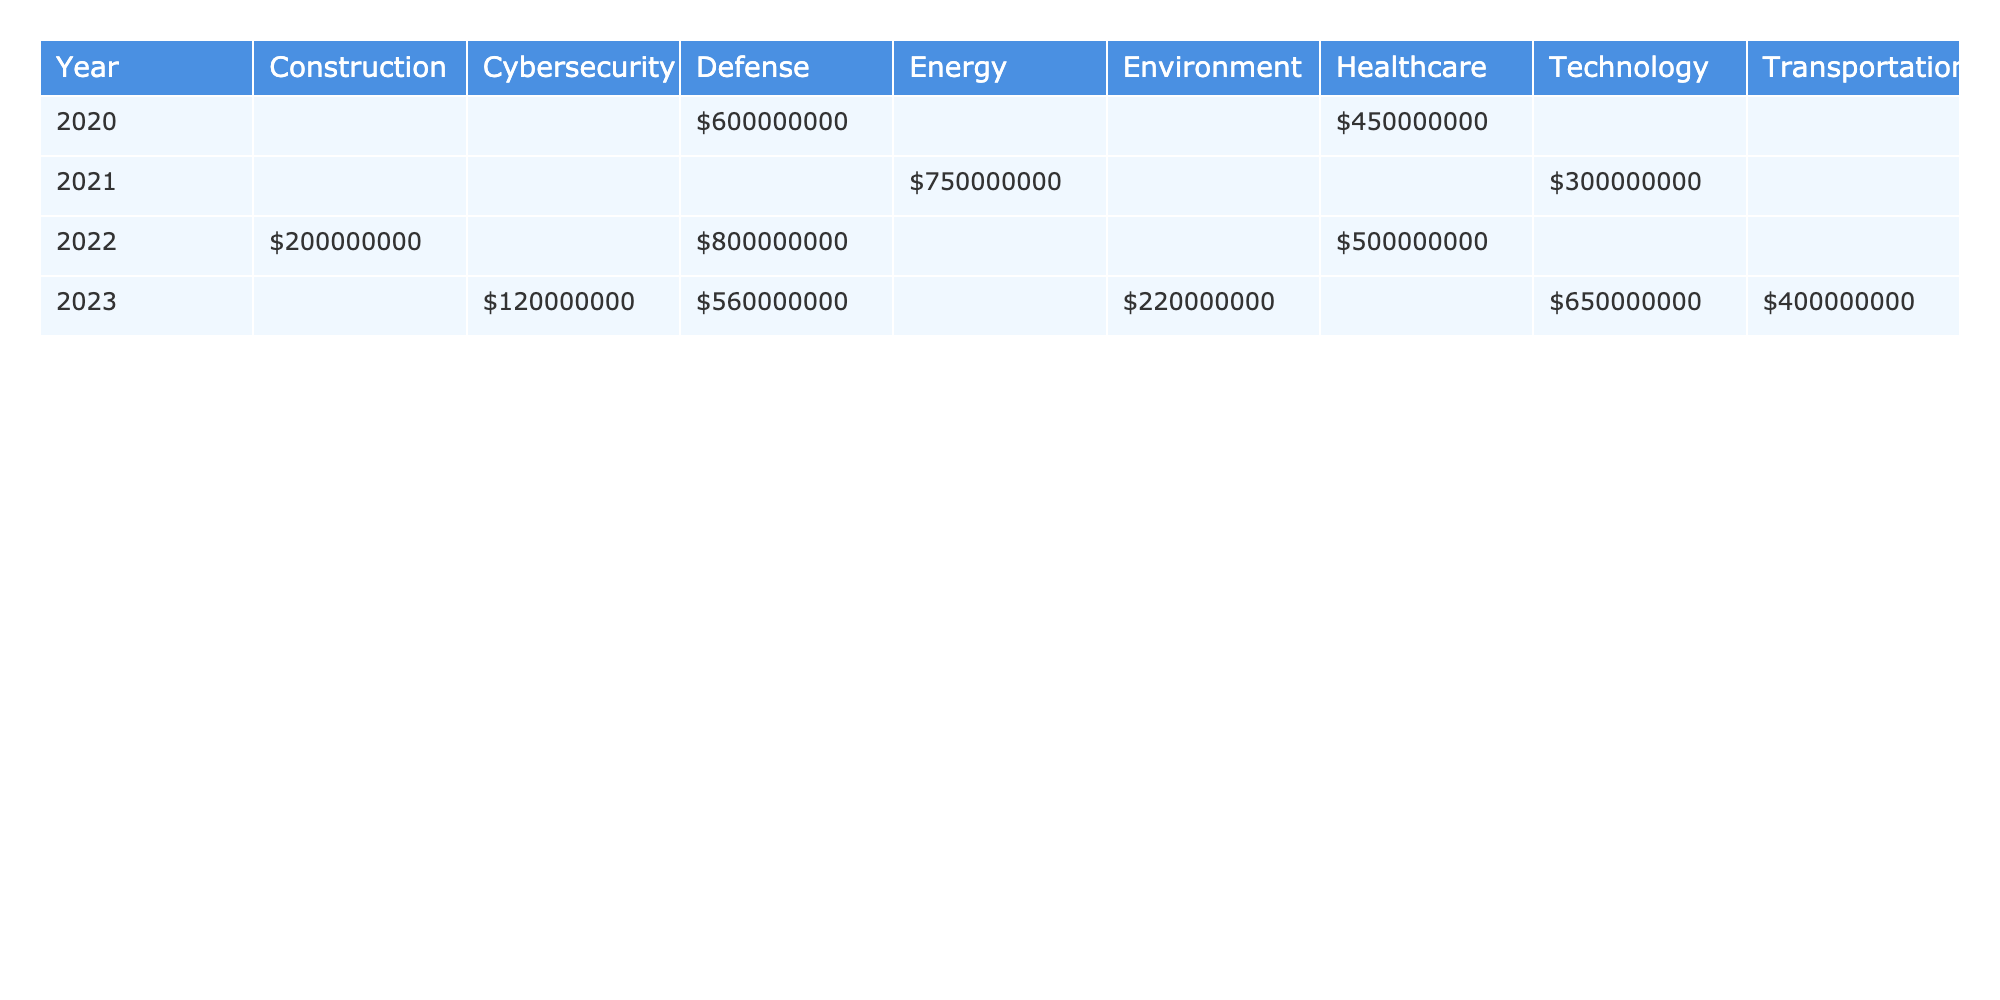What was the total contract value awarded in the year 2022? The contract values for 2022 in the table are $200,000,000 (Construction) + $500,000,000 (Healthcare) + $800,000,000 (Defense), which sums to $200,000,000 + $500,000,000 + $800,000,000 = $1,500,000,000.
Answer: $1,500,000,000 Which industry received the highest contract value in 2021? In 2021, the contract values are $750,000,000 (Energy) and $300,000,000 (Technology). The highest value is $750,000,000 in the Energy industry.
Answer: Energy Did any company in the healthcare industry receive contracts in 2020? Yes, McKesson Corporation received a contract worth $450,000,000 in the healthcare industry in 2020.
Answer: Yes What is the average contract value for the defense industry across all years? The contract values for the defense industry are $600,000,000 (2020) + $800,000,000 (2022) + $560,000,000 (2023). This adds up to $600,000,000 + $800,000,000 + $560,000,000 = $1,960,000,000. There are 3 data points, so the average is $1,960,000,000 / 3 = $653,333,333.33.
Answer: $653,333,333.33 Which year saw the least amount of government contracts awarded in total? To find the total for each year, we calculate: 2020: $600,000,000 + $450,000,000 = $1,050,000,000; 2021: $750,000,000 + $300,000,000 = $1,050,000,000; 2022: $200,000,000 + $500,000,000 + $800,000,000 = $1,500,000,000; 2023: $120,000,000 + $400,000,000 + $650,000,000 + $220,000,000 + $560,000,000 = $2,050,000,000. The least is $1,050,000,000 for 2020 and 2021.
Answer: 2020 and 2021 How many unique companies were awarded contracts in 2022? In 2022, the companies mentioned are Beginnings LLC, Johnson & Johnson, and Boeing. There are 3 unique companies.
Answer: 3 Was there a contract for construction in the year 2021? No, the table does not list any construction contracts for 2021; it shows contracts only for energy and technology.
Answer: No Which industry had the most diverse representation in terms of contract types across the years? The industries listed are Defense, Healthcare, Energy, Technology, Construction, Cybersecurity, Transportation, and Environment. Defense has contracts for both goods and services (2020: goods, 2022: services, 2023: goods), showing diversity in contract types.
Answer: Defense What is the total amount awarded to the technology industry across all years? The contracts in the technology industry are $300,000,000 (2021) and $650,000,000 (2023). The total is $300,000,000 + $650,000,000 = $950,000,000.
Answer: $950,000,000 